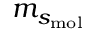<formula> <loc_0><loc_0><loc_500><loc_500>m _ { s _ { m o l } }</formula> 